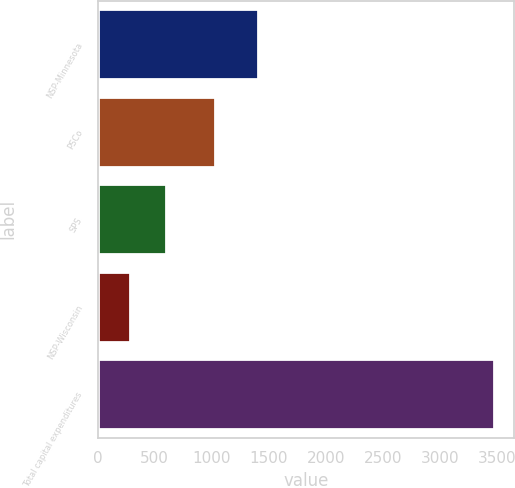Convert chart to OTSL. <chart><loc_0><loc_0><loc_500><loc_500><bar_chart><fcel>NSP-Minnesota<fcel>PSCo<fcel>SPS<fcel>NSP-Wisconsin<fcel>Total capital expenditures<nl><fcel>1405<fcel>1030<fcel>599.5<fcel>280<fcel>3475<nl></chart> 